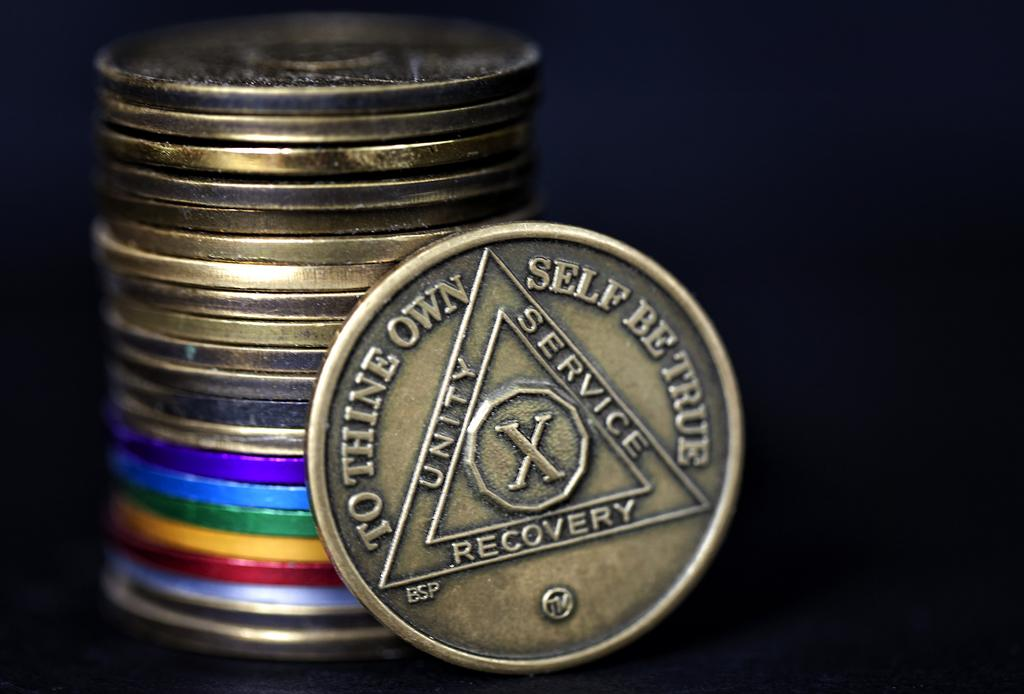<image>
Render a clear and concise summary of the photo. brass coins stacked up and one reads "To thine own self be true" 